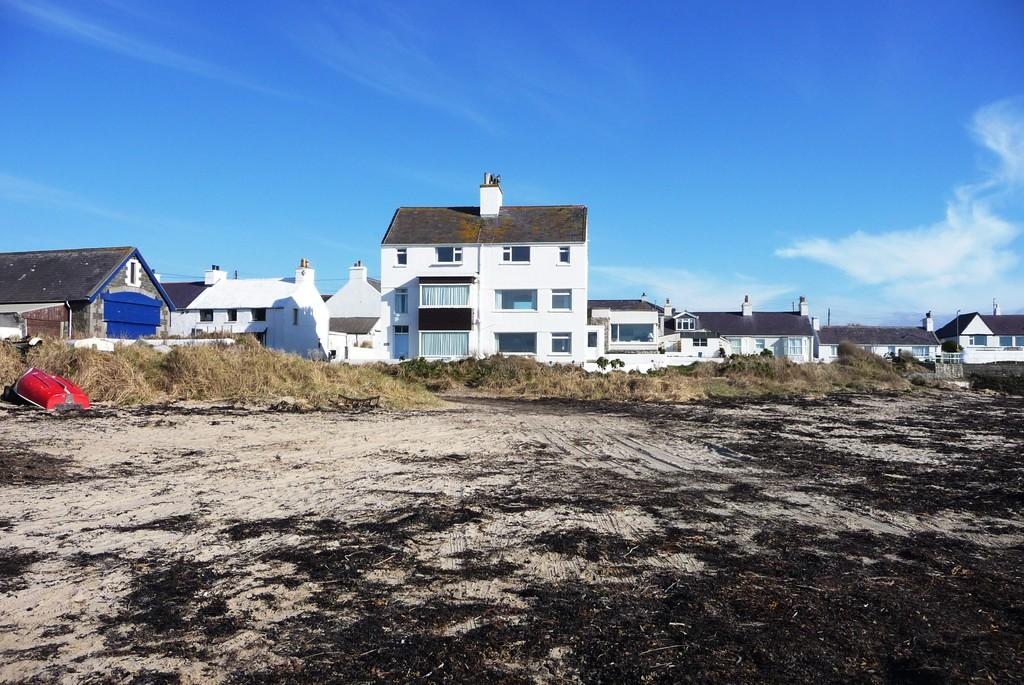What is the color of the object in the image? The object in the image is red. What type of vegetation can be seen in the image? There is dried grass in the image. What colors are the buildings in the image? The buildings in the image are brown and white. What is the color of the sky in the image? The sky is blue and white in the image. Is the man in the image reading a book while wearing a lawyer's robe? There is no man or lawyer's robe present in the image. 